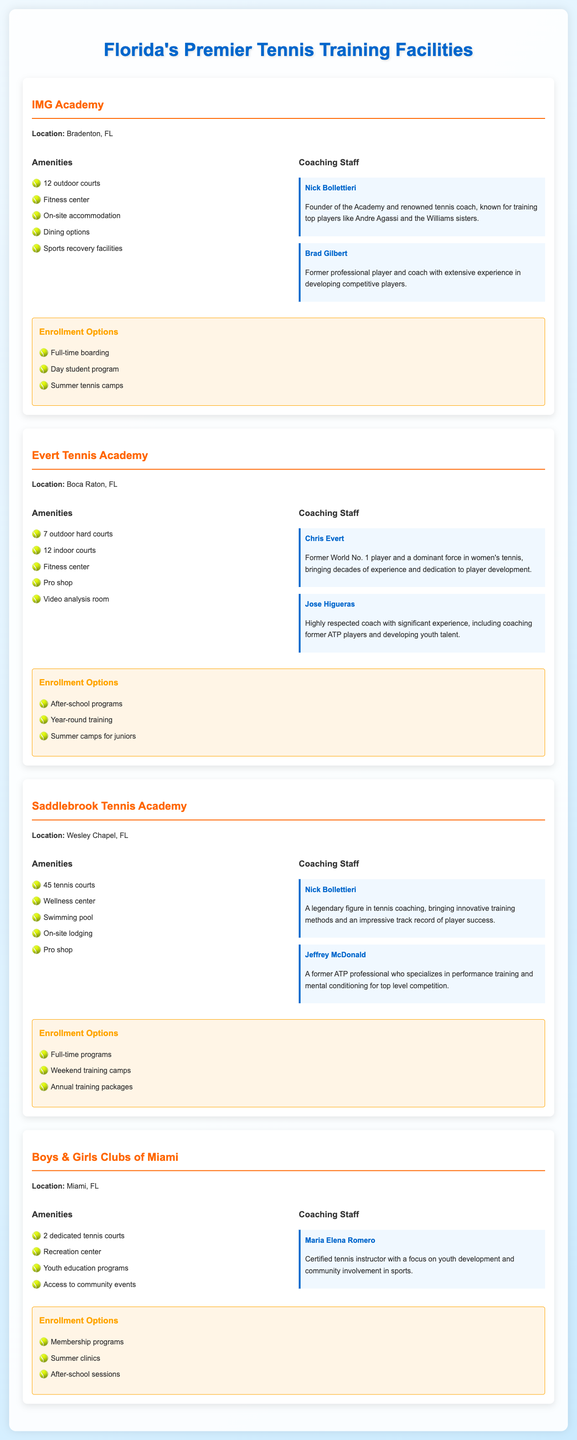what is the location of IMG Academy? The location of IMG Academy is mentioned as Bradenton, FL.
Answer: Bradenton, FL how many outdoor courts does Evert Tennis Academy have? The document states that Evert Tennis Academy has 7 outdoor hard courts.
Answer: 7 outdoor hard courts who is the founder of IMG Academy? The founder of IMG Academy is Nick Bollettieri, as indicated in the coaching staff section.
Answer: Nick Bollettieri how many tennis courts are available at Saddlebrook Tennis Academy? The document specifies that Saddlebrook Tennis Academy has 45 tennis courts.
Answer: 45 tennis courts which facility has a video analysis room? The Evert Tennis Academy is noted for having a video analysis room in the amenities.
Answer: Evert Tennis Academy what enrollment options does Boys & Girls Clubs of Miami offer? The enrollment options listed for Boys & Girls Clubs of Miami include membership programs, summer clinics, and after-school sessions.
Answer: Membership programs, summer clinics, after-school sessions who is the notable coach at Saddlebrook Tennis Academy? Nick Bollettieri is mentioned as a legendary figure and a notable coach at Saddlebrook Tennis Academy.
Answer: Nick Bollettieri what type of training does Jeffrey McDonald specialize in? Jeffrey McDonald specializes in performance training and mental conditioning for top level competition.
Answer: Performance training and mental conditioning how many indoor courts are available at Evert Tennis Academy? The document states that Evert Tennis Academy has 12 indoor courts.
Answer: 12 indoor courts 